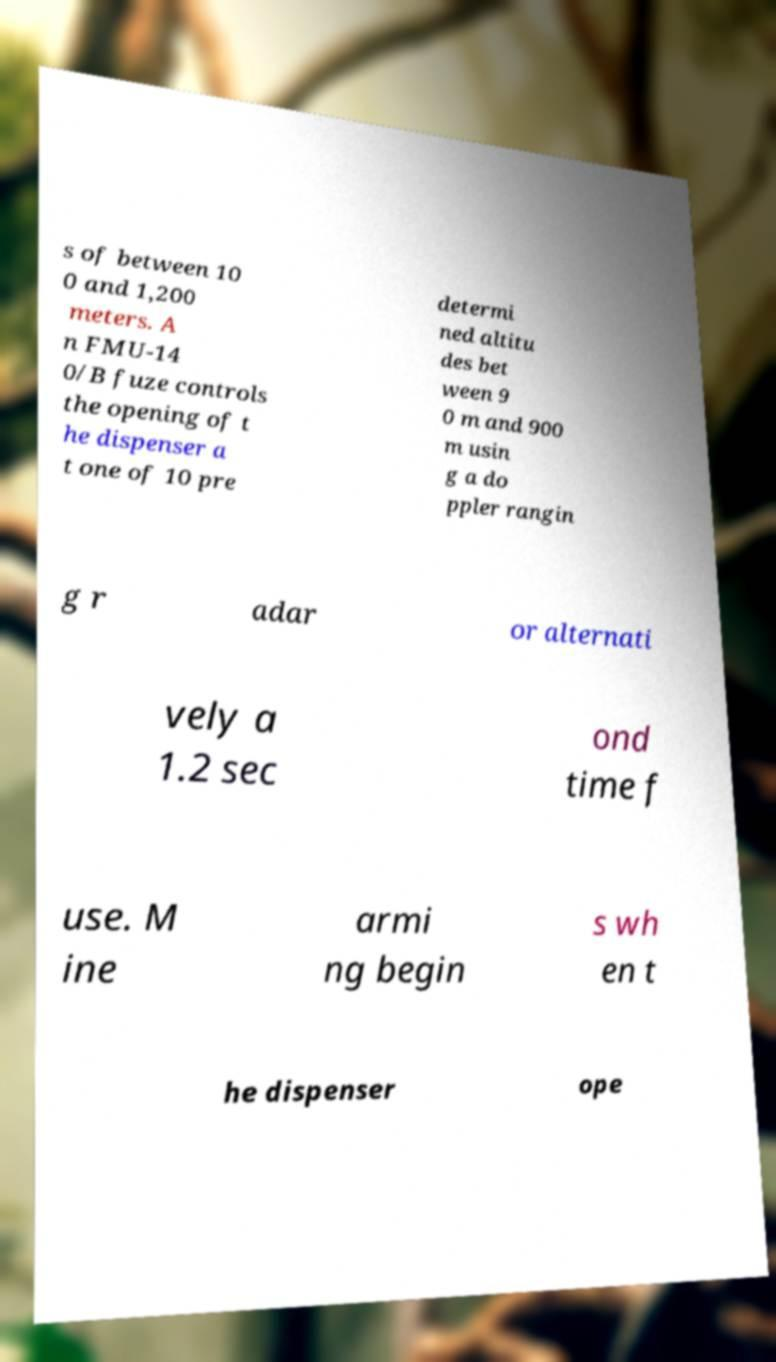Can you accurately transcribe the text from the provided image for me? s of between 10 0 and 1,200 meters. A n FMU-14 0/B fuze controls the opening of t he dispenser a t one of 10 pre determi ned altitu des bet ween 9 0 m and 900 m usin g a do ppler rangin g r adar or alternati vely a 1.2 sec ond time f use. M ine armi ng begin s wh en t he dispenser ope 